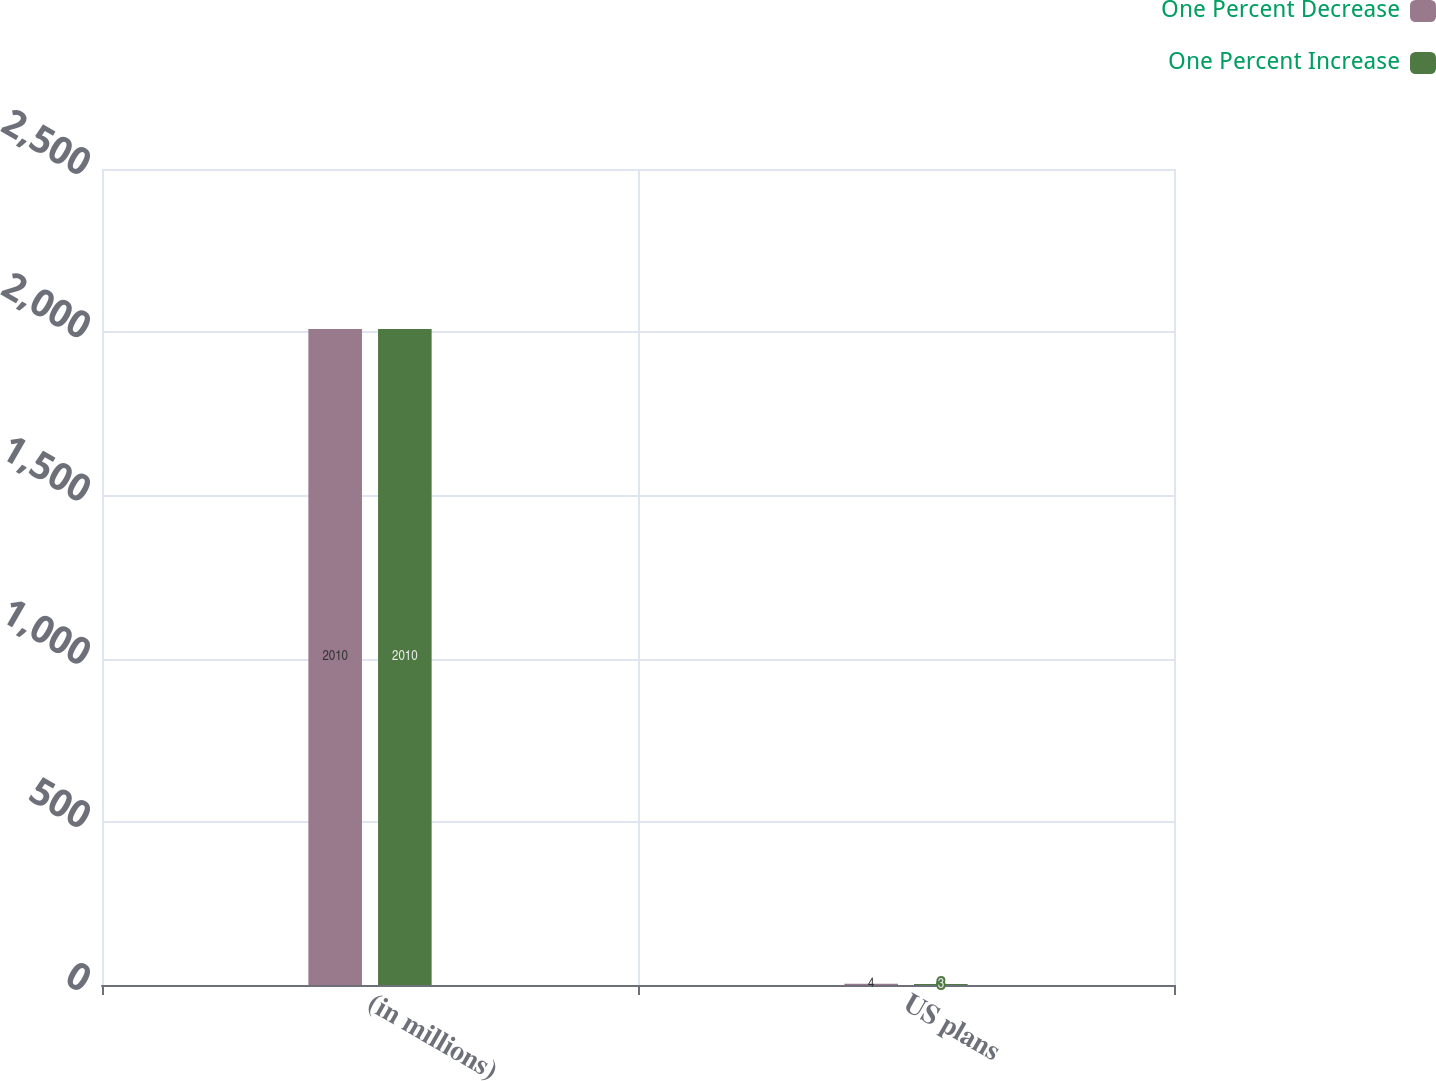<chart> <loc_0><loc_0><loc_500><loc_500><stacked_bar_chart><ecel><fcel>(in millions)<fcel>US plans<nl><fcel>One Percent Decrease<fcel>2010<fcel>4<nl><fcel>One Percent Increase<fcel>2010<fcel>3<nl></chart> 